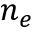Convert formula to latex. <formula><loc_0><loc_0><loc_500><loc_500>n _ { e }</formula> 